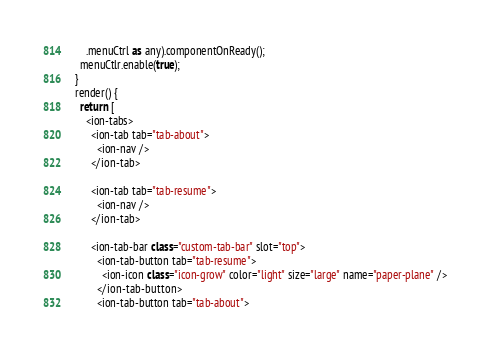<code> <loc_0><loc_0><loc_500><loc_500><_TypeScript_>      .menuCtrl as any).componentOnReady();
    menuCtlr.enable(true);
  }
  render() {
    return [
      <ion-tabs>
        <ion-tab tab="tab-about">
          <ion-nav />
        </ion-tab>

        <ion-tab tab="tab-resume">
          <ion-nav />
        </ion-tab>

        <ion-tab-bar class="custom-tab-bar" slot="top">
          <ion-tab-button tab="tab-resume">
            <ion-icon class="icon-grow" color="light" size="large" name="paper-plane" />
          </ion-tab-button>
          <ion-tab-button tab="tab-about"></code> 